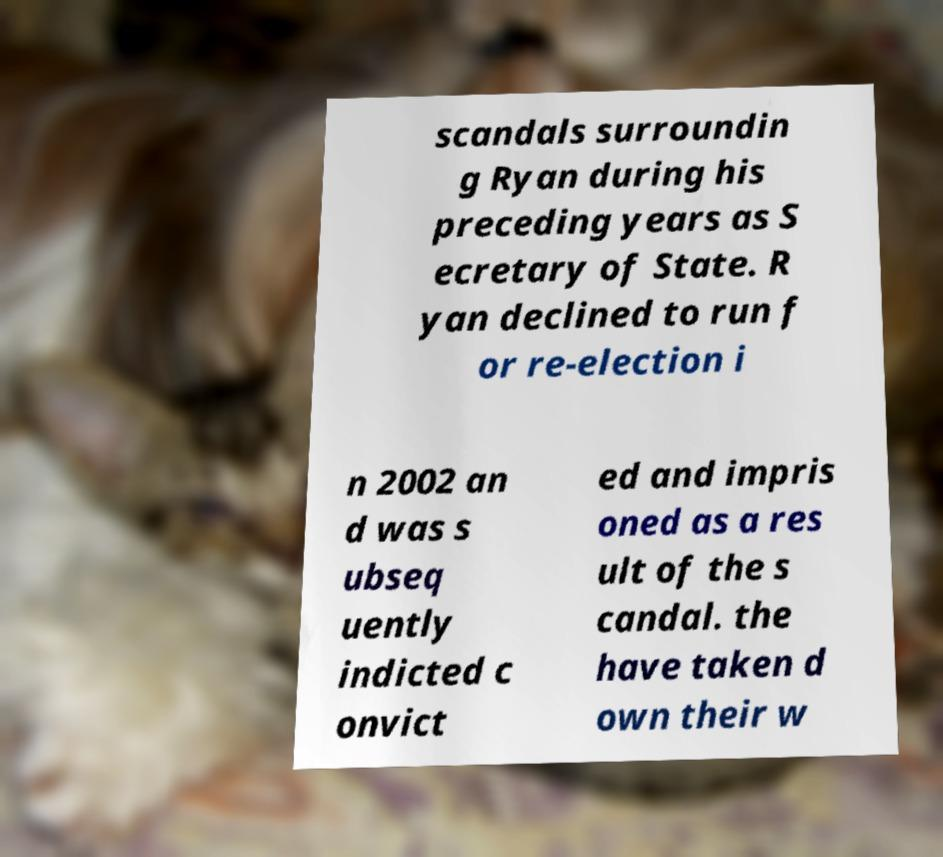Can you read and provide the text displayed in the image?This photo seems to have some interesting text. Can you extract and type it out for me? scandals surroundin g Ryan during his preceding years as S ecretary of State. R yan declined to run f or re-election i n 2002 an d was s ubseq uently indicted c onvict ed and impris oned as a res ult of the s candal. the have taken d own their w 